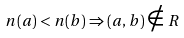Convert formula to latex. <formula><loc_0><loc_0><loc_500><loc_500>n ( a ) < n ( b ) \Rightarrow ( a , b ) \notin R</formula> 